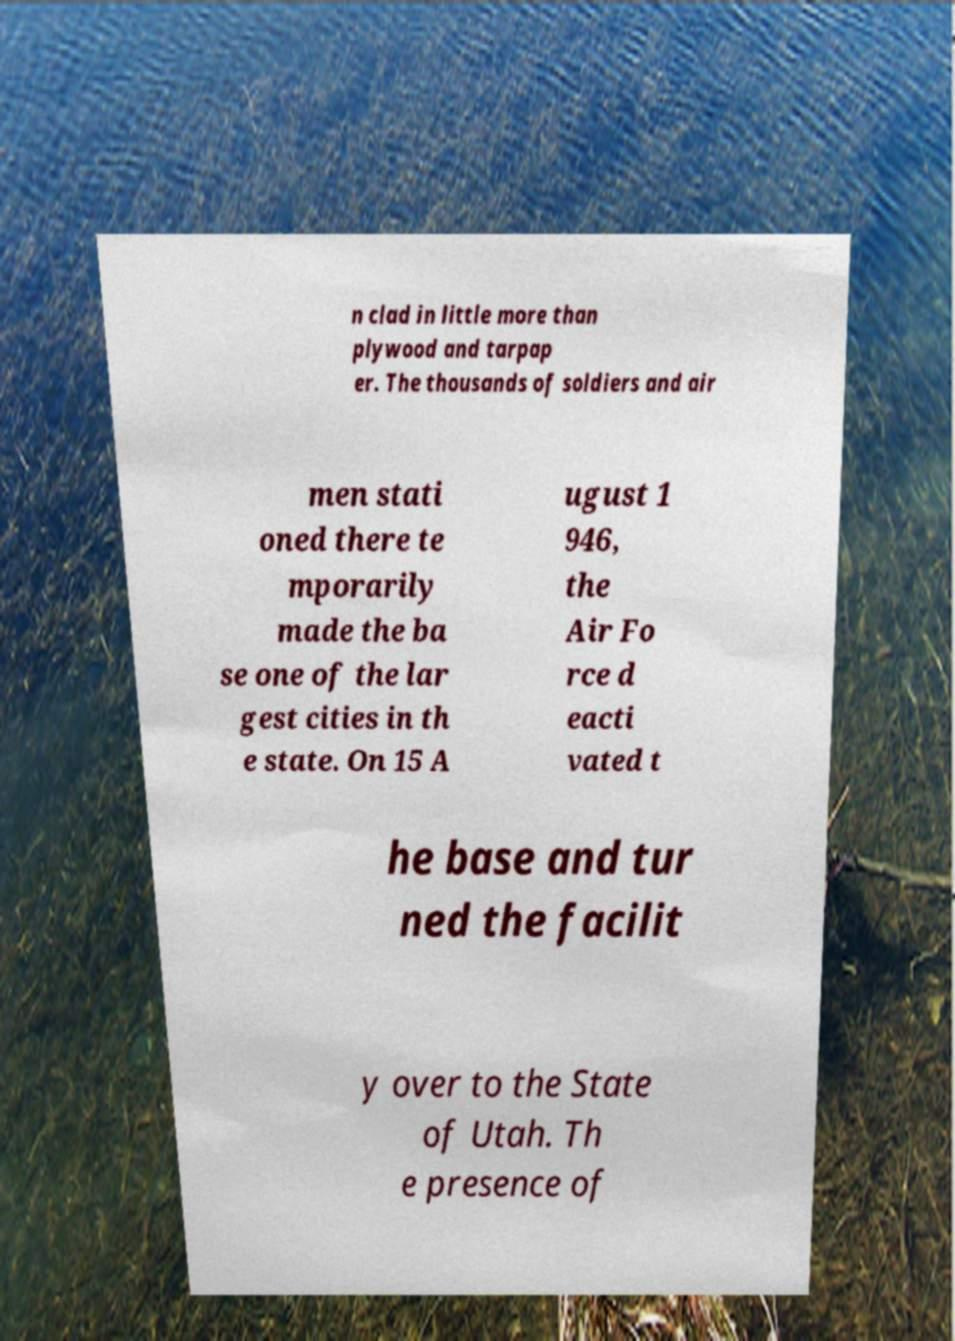I need the written content from this picture converted into text. Can you do that? n clad in little more than plywood and tarpap er. The thousands of soldiers and air men stati oned there te mporarily made the ba se one of the lar gest cities in th e state. On 15 A ugust 1 946, the Air Fo rce d eacti vated t he base and tur ned the facilit y over to the State of Utah. Th e presence of 